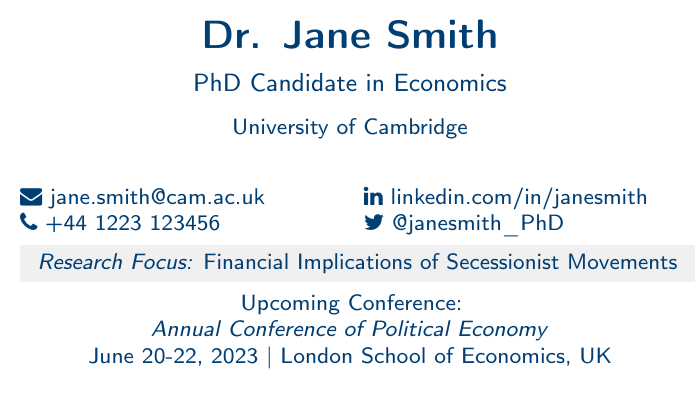What is the name of the PhD candidate? The document displays the name prominently at the top as "Dr. Jane Smith."
Answer: Dr. Jane Smith What is Dr. Jane Smith's email address? The contact information includes an email section where her email is stated clearly.
Answer: jane.smith@cam.ac.uk When is the upcoming conference? The conference date is listed under "Upcoming Conference" as "June 20-22, 2023."
Answer: June 20-22, 2023 Where is the Annual Conference of Political Economy being held? The location of the conference is mentioned along with the event details in the document.
Answer: London School of Economics, UK What is the research focus of Dr. Jane Smith? The document provides a section detailing her research focus clearly.
Answer: Financial Implications of Secessionist Movements How is Dr. Jane Smith connected on social media? The document mentions her Twitter handle specifically among other contact details.
Answer: @janesmith_PhD What type of document is this? The document is specifically formatted as a business card, evident from its title and layout.
Answer: Business card What university is Dr. Jane Smith affiliated with? The document states her university affiliation in a dedicated line.
Answer: University of Cambridge What is Dr. Jane Smith's phone number? The contact section includes her phone number explicitly formatted.
Answer: +44 1223 123456 